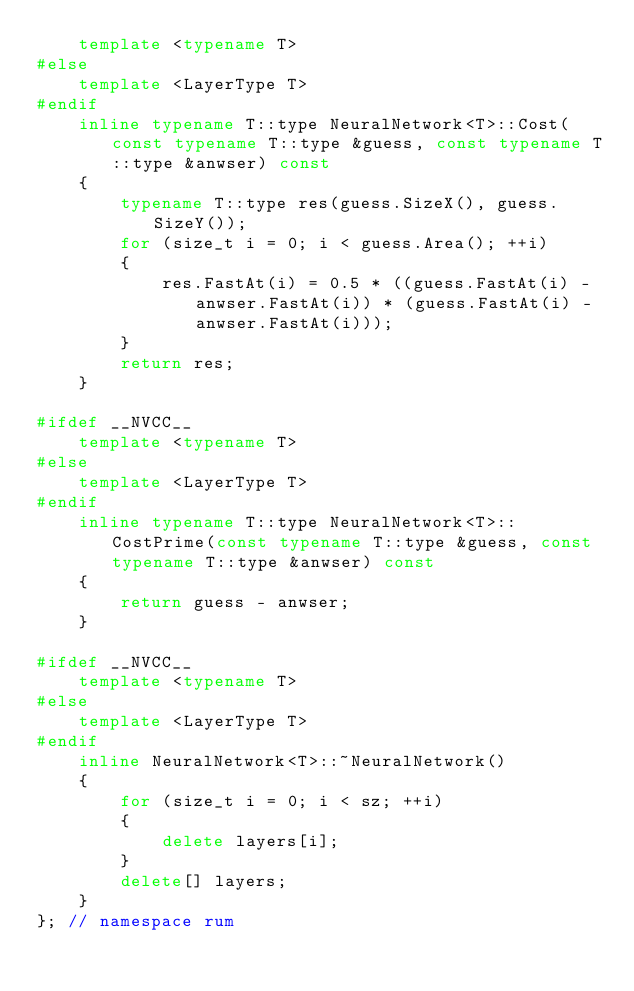Convert code to text. <code><loc_0><loc_0><loc_500><loc_500><_C++_>    template <typename T>
#else
    template <LayerType T>
#endif
    inline typename T::type NeuralNetwork<T>::Cost(const typename T::type &guess, const typename T::type &anwser) const
    {
        typename T::type res(guess.SizeX(), guess.SizeY());
        for (size_t i = 0; i < guess.Area(); ++i)
        {
            res.FastAt(i) = 0.5 * ((guess.FastAt(i) - anwser.FastAt(i)) * (guess.FastAt(i) - anwser.FastAt(i)));
        }
        return res;
    }

#ifdef __NVCC__
    template <typename T>
#else
    template <LayerType T>
#endif
    inline typename T::type NeuralNetwork<T>::CostPrime(const typename T::type &guess, const typename T::type &anwser) const
    {
        return guess - anwser;
    }

#ifdef __NVCC__
    template <typename T>
#else
    template <LayerType T>
#endif
    inline NeuralNetwork<T>::~NeuralNetwork()
    {
        for (size_t i = 0; i < sz; ++i)
        {
            delete layers[i];
        }
        delete[] layers;
    }
}; // namespace rum
</code> 